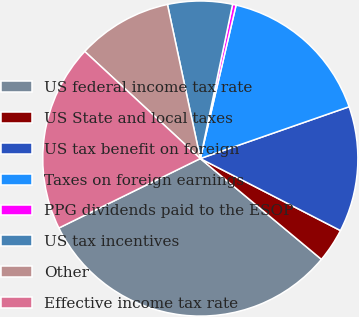Convert chart to OTSL. <chart><loc_0><loc_0><loc_500><loc_500><pie_chart><fcel>US federal income tax rate<fcel>US State and local taxes<fcel>US tax benefit on foreign<fcel>Taxes on foreign earnings<fcel>PPG dividends paid to the ESOP<fcel>US tax incentives<fcel>Other<fcel>Effective income tax rate<nl><fcel>31.69%<fcel>3.49%<fcel>12.89%<fcel>16.02%<fcel>0.36%<fcel>6.63%<fcel>9.76%<fcel>19.16%<nl></chart> 